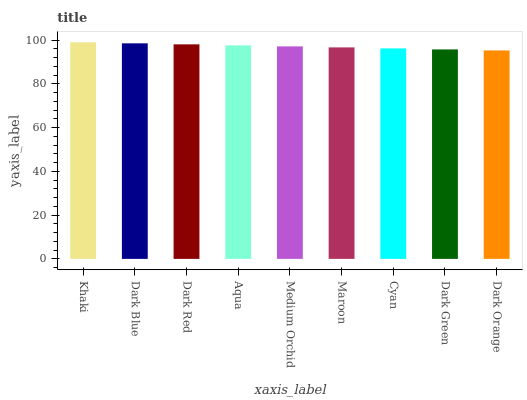Is Dark Orange the minimum?
Answer yes or no. Yes. Is Khaki the maximum?
Answer yes or no. Yes. Is Dark Blue the minimum?
Answer yes or no. No. Is Dark Blue the maximum?
Answer yes or no. No. Is Khaki greater than Dark Blue?
Answer yes or no. Yes. Is Dark Blue less than Khaki?
Answer yes or no. Yes. Is Dark Blue greater than Khaki?
Answer yes or no. No. Is Khaki less than Dark Blue?
Answer yes or no. No. Is Medium Orchid the high median?
Answer yes or no. Yes. Is Medium Orchid the low median?
Answer yes or no. Yes. Is Aqua the high median?
Answer yes or no. No. Is Cyan the low median?
Answer yes or no. No. 